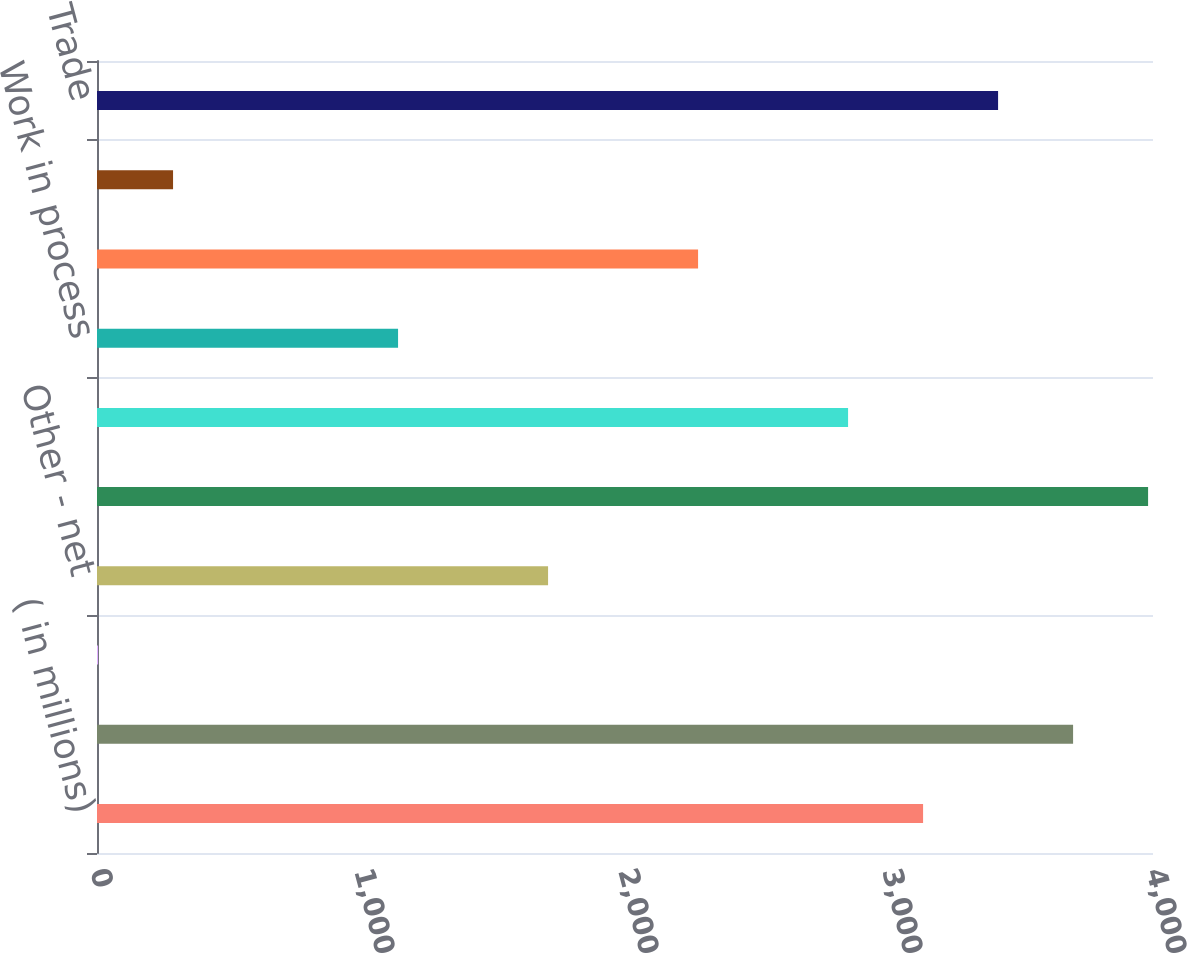Convert chart to OTSL. <chart><loc_0><loc_0><loc_500><loc_500><bar_chart><fcel>( in millions)<fcel>Trade - net (1)<fcel>Equity affiliates<fcel>Other - net<fcel>Total<fcel>Finished products<fcel>Work in process<fcel>Raw materials<fcel>Supplies<fcel>Trade<nl><fcel>3129.1<fcel>3697.3<fcel>4<fcel>1708.6<fcel>3981.4<fcel>2845<fcel>1140.4<fcel>2276.8<fcel>288.1<fcel>3413.2<nl></chart> 